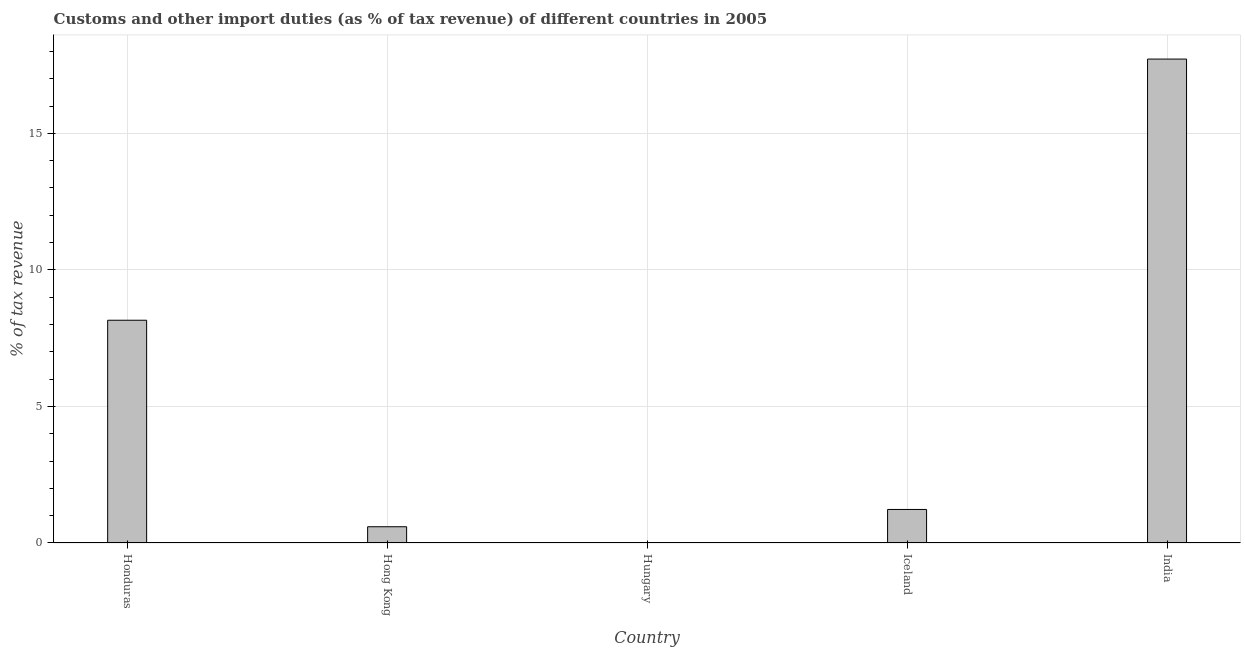Does the graph contain grids?
Keep it short and to the point. Yes. What is the title of the graph?
Offer a very short reply. Customs and other import duties (as % of tax revenue) of different countries in 2005. What is the label or title of the Y-axis?
Ensure brevity in your answer.  % of tax revenue. What is the customs and other import duties in India?
Keep it short and to the point. 17.72. Across all countries, what is the maximum customs and other import duties?
Keep it short and to the point. 17.72. Across all countries, what is the minimum customs and other import duties?
Offer a terse response. 0. What is the sum of the customs and other import duties?
Keep it short and to the point. 27.7. What is the difference between the customs and other import duties in Honduras and India?
Provide a succinct answer. -9.56. What is the average customs and other import duties per country?
Ensure brevity in your answer.  5.54. What is the median customs and other import duties?
Keep it short and to the point. 1.23. What is the ratio of the customs and other import duties in Iceland to that in India?
Give a very brief answer. 0.07. Is the customs and other import duties in Honduras less than that in India?
Your response must be concise. Yes. What is the difference between the highest and the second highest customs and other import duties?
Keep it short and to the point. 9.56. What is the difference between the highest and the lowest customs and other import duties?
Offer a terse response. 17.72. How many bars are there?
Make the answer very short. 4. Are all the bars in the graph horizontal?
Offer a terse response. No. How many countries are there in the graph?
Your answer should be compact. 5. Are the values on the major ticks of Y-axis written in scientific E-notation?
Provide a short and direct response. No. What is the % of tax revenue of Honduras?
Your answer should be very brief. 8.16. What is the % of tax revenue in Hong Kong?
Provide a succinct answer. 0.59. What is the % of tax revenue of Iceland?
Provide a short and direct response. 1.23. What is the % of tax revenue of India?
Give a very brief answer. 17.72. What is the difference between the % of tax revenue in Honduras and Hong Kong?
Give a very brief answer. 7.56. What is the difference between the % of tax revenue in Honduras and Iceland?
Ensure brevity in your answer.  6.93. What is the difference between the % of tax revenue in Honduras and India?
Make the answer very short. -9.56. What is the difference between the % of tax revenue in Hong Kong and Iceland?
Provide a short and direct response. -0.63. What is the difference between the % of tax revenue in Hong Kong and India?
Provide a succinct answer. -17.12. What is the difference between the % of tax revenue in Iceland and India?
Provide a succinct answer. -16.49. What is the ratio of the % of tax revenue in Honduras to that in Hong Kong?
Ensure brevity in your answer.  13.72. What is the ratio of the % of tax revenue in Honduras to that in Iceland?
Offer a very short reply. 6.64. What is the ratio of the % of tax revenue in Honduras to that in India?
Offer a terse response. 0.46. What is the ratio of the % of tax revenue in Hong Kong to that in Iceland?
Your answer should be compact. 0.48. What is the ratio of the % of tax revenue in Hong Kong to that in India?
Offer a terse response. 0.03. What is the ratio of the % of tax revenue in Iceland to that in India?
Your answer should be very brief. 0.07. 